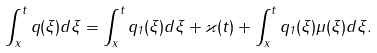Convert formula to latex. <formula><loc_0><loc_0><loc_500><loc_500>\int _ { x } ^ { t } q ( \xi ) d \xi = \int _ { x } ^ { t } q _ { 1 } ( \xi ) d \xi + \varkappa ( t ) + \int _ { x } ^ { t } q _ { 1 } ( \xi ) \mu ( \xi ) d \xi .</formula> 